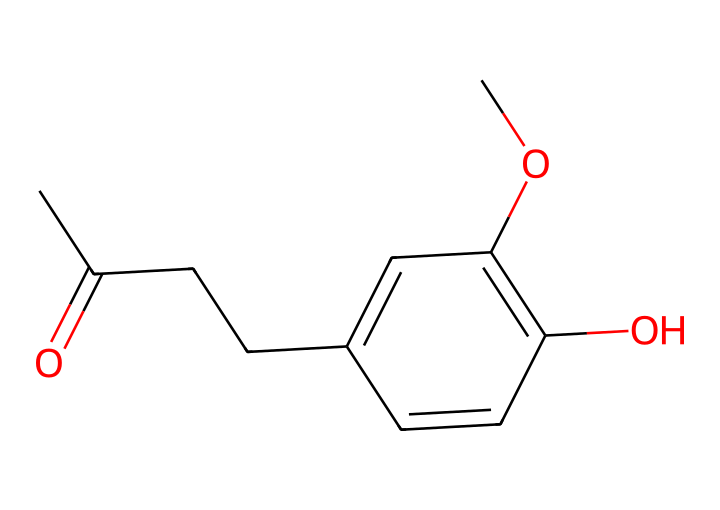What is the main functional group present in raspberry ketone? The chemical structure includes a carbonyl group (C=O) which is characteristic of ketones. It can be identified from the SMILES representation where “C(=O)” signifies the carbonyl functionality.
Answer: carbonyl group How many carbon atoms are in raspberry ketone? By analyzing the SMILES representation, we count the number of 'C' characters. There are 10 carbon atoms present in the structure.
Answer: 10 What is the molecular weight of raspberry ketone? To find the molecular weight, we sum the atomic weights of all atoms present in the chemical structure. Based on the structure, the molecular weight is calculated to be approximately 162.23 g/mol.
Answer: 162.23 g/mol Which part of the molecule indicates it is a ketone? The presence of the carbonyl functional group (C=O) is the defining feature of ketones. In the SMILES, "C(=O)" directly signifies this functional group.
Answer: carbonyl How many hydroxyl (-OH) groups are in raspberry ketone? Looking closely at the SMILES representation, we find one hydroxyl group indicated by “O” attached to a carbon, confirming the presence of a single -OH group.
Answer: 1 What type of compound is raspberry ketone classified as? Given the presence of the carbonyl functional group along with its specific molecular structure, raspberry ketone falls under the category of ketones.
Answer: ketone Which ring structure is present in raspberry ketone? The cyclic portion of the molecule is indicated by the presence of “C1=CC” in the SMILES, which indicates a benzene-like ring structure as part of its configuration.
Answer: benzene ring 